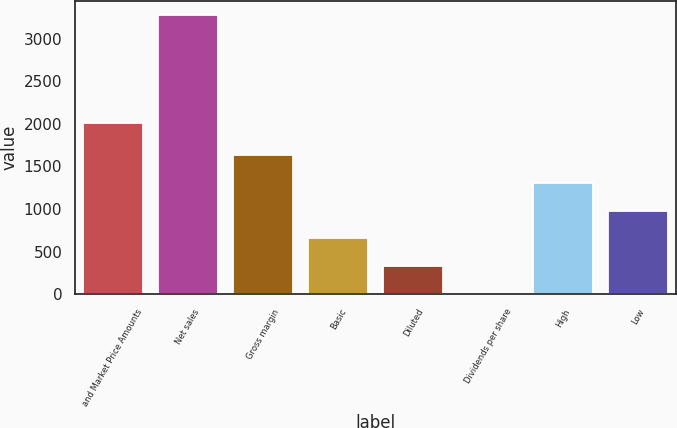Convert chart to OTSL. <chart><loc_0><loc_0><loc_500><loc_500><bar_chart><fcel>and Market Price Amounts<fcel>Net sales<fcel>Gross margin<fcel>Basic<fcel>Diluted<fcel>Dividends per share<fcel>High<fcel>Low<nl><fcel>2006<fcel>3273<fcel>1636.68<fcel>654.87<fcel>327.6<fcel>0.33<fcel>1309.41<fcel>982.14<nl></chart> 